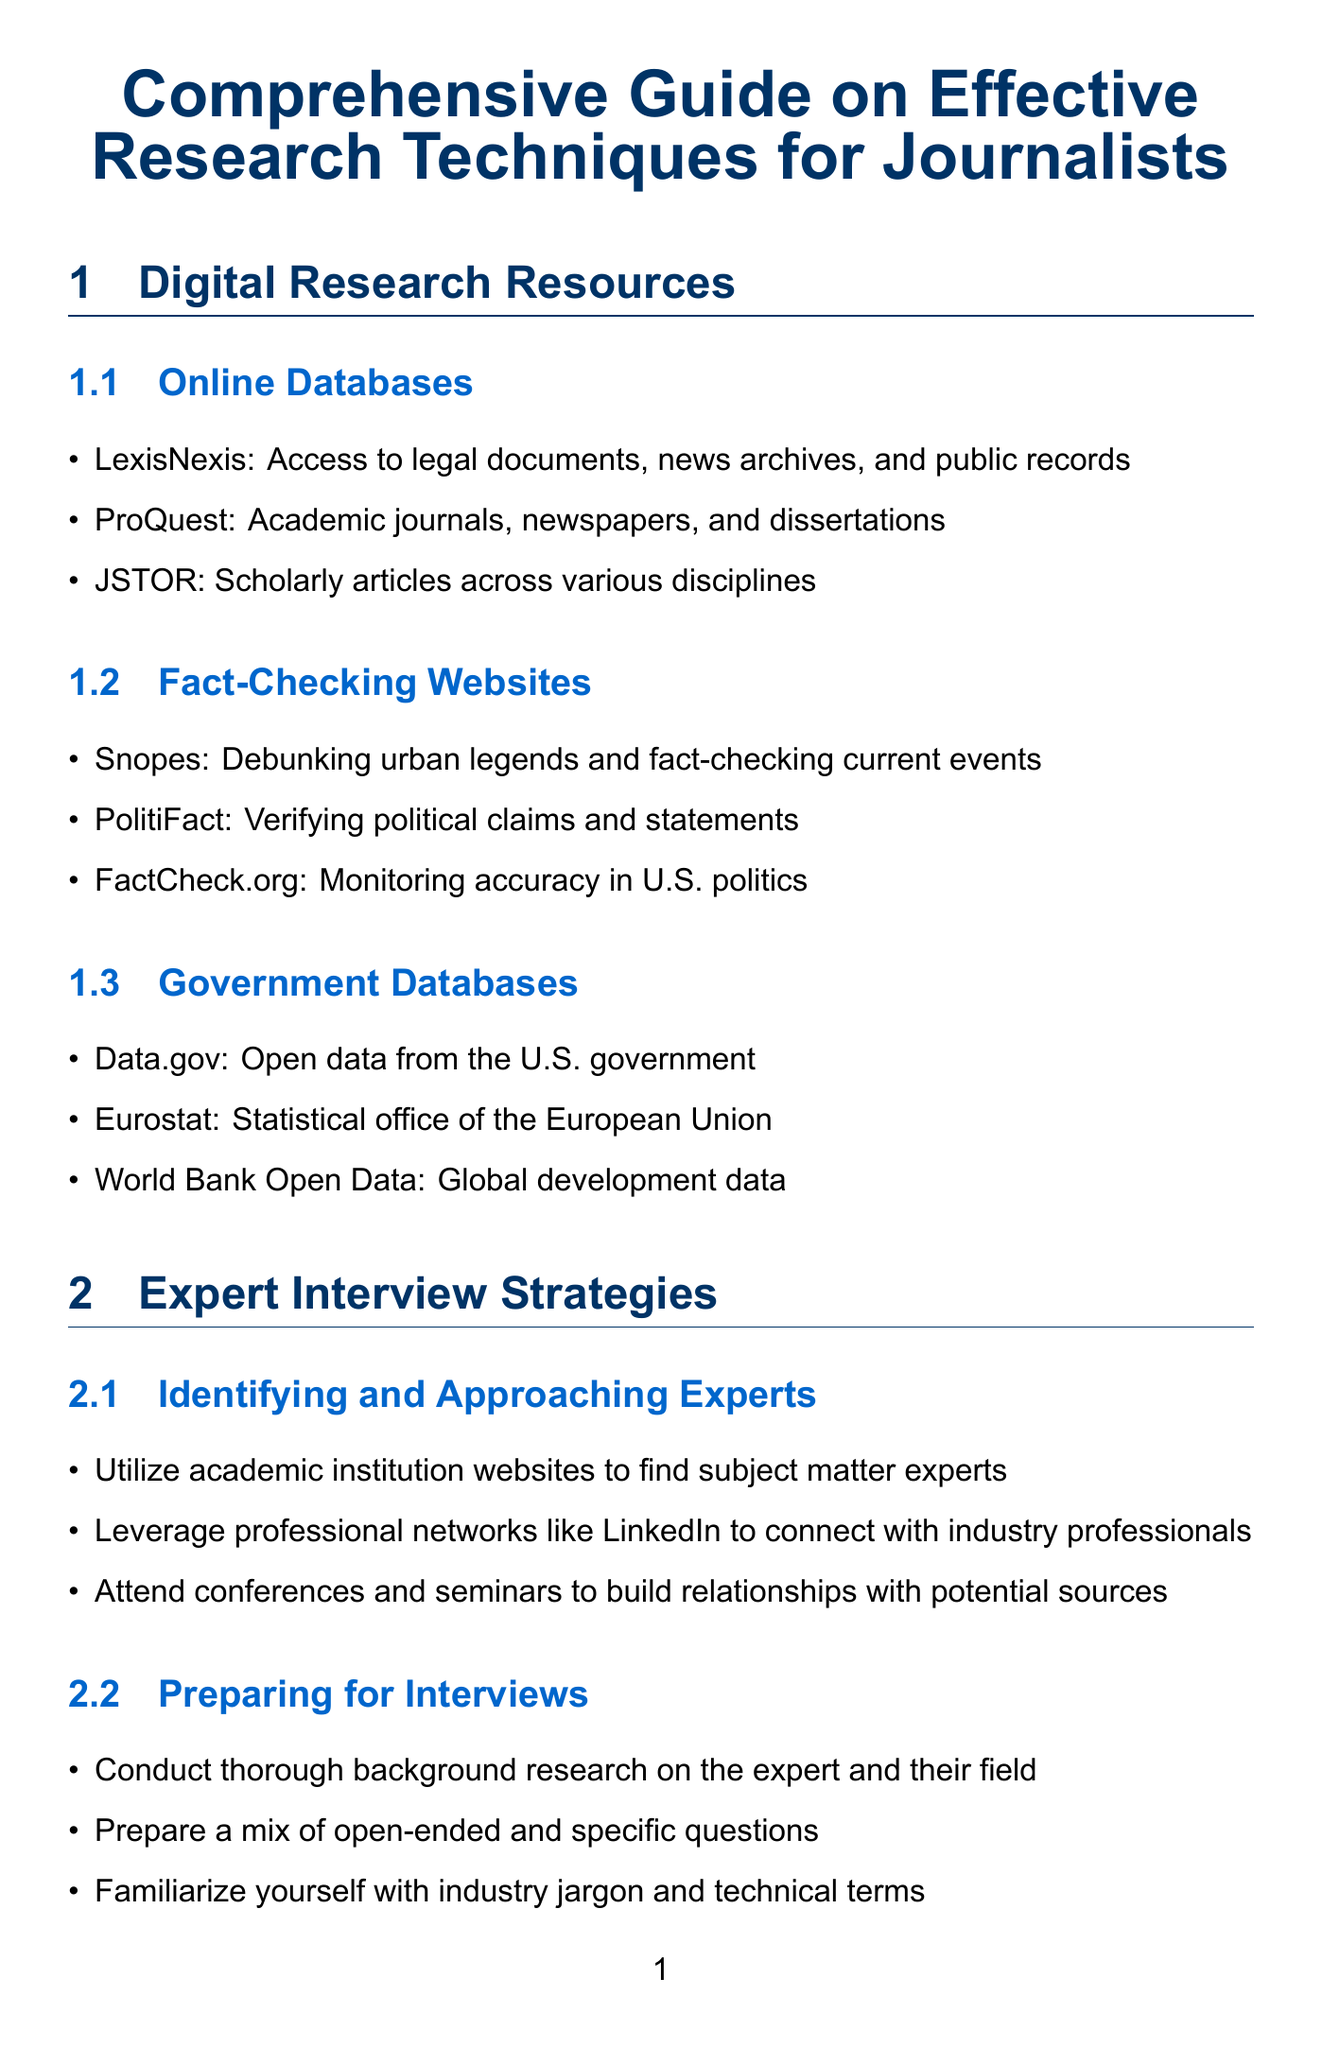what is one online database mentioned? The document lists several online databases for research, such as LexisNexis, ProQuest, and JSTOR.
Answer: LexisNexis name one website for fact-checking political statements The document outlines specific fact-checking websites, one of which is dedicated to verifying political claims.
Answer: PolitiFact what tool is suggested for basic data analysis? The document includes various tools categorized under data analysis, including Microsoft Excel.
Answer: Microsoft Excel what is a recommended approach for building relationships with experts? The document suggests several methods for connecting with experts, one being attending specific events.
Answer: Attend conferences which software is noted for creating interactive visualizations? Within the document's data visualization tools, there are specific software options for creating visual content, including one particular JavaScript library.
Answer: D3.js what is a best practice for data journalism? The document defines practices that enhance the credibility of data journalism, including a specific action to verify sources.
Answer: Verify data sources how should an article be structured according to the guide? The document provides a format for structuring articles, highlighting a specific method involving information organization.
Answer: Inverted pyramid structure what secure communication method is mentioned? The document advises on secure communication methods for journalists, naming specific applications to use for sensitive information.
Answer: Signal 